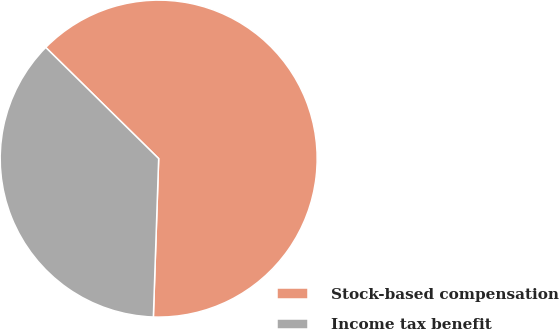<chart> <loc_0><loc_0><loc_500><loc_500><pie_chart><fcel>Stock-based compensation<fcel>Income tax benefit<nl><fcel>63.16%<fcel>36.84%<nl></chart> 